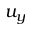<formula> <loc_0><loc_0><loc_500><loc_500>u _ { y }</formula> 